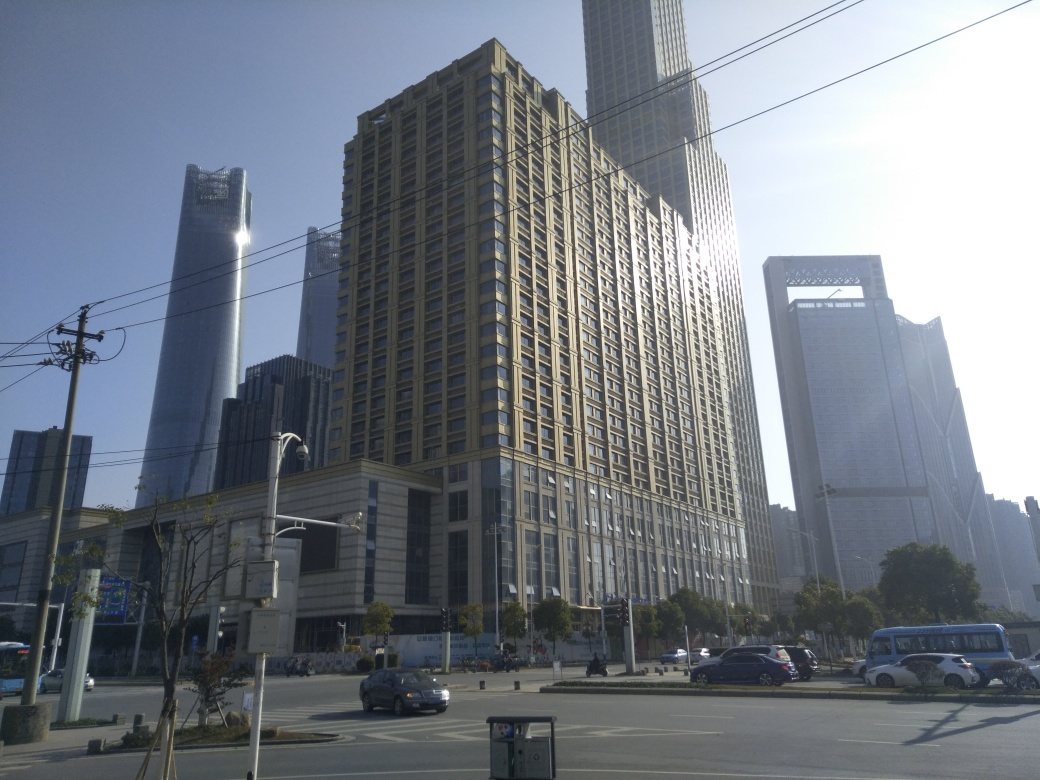What style of architecture is predominant in the buildings pictured? The buildings in the image exhibit modern architectural styles, characterized by the use of contemporary materials such as glass and steel and the presence of sleek, geometric lines and form. 